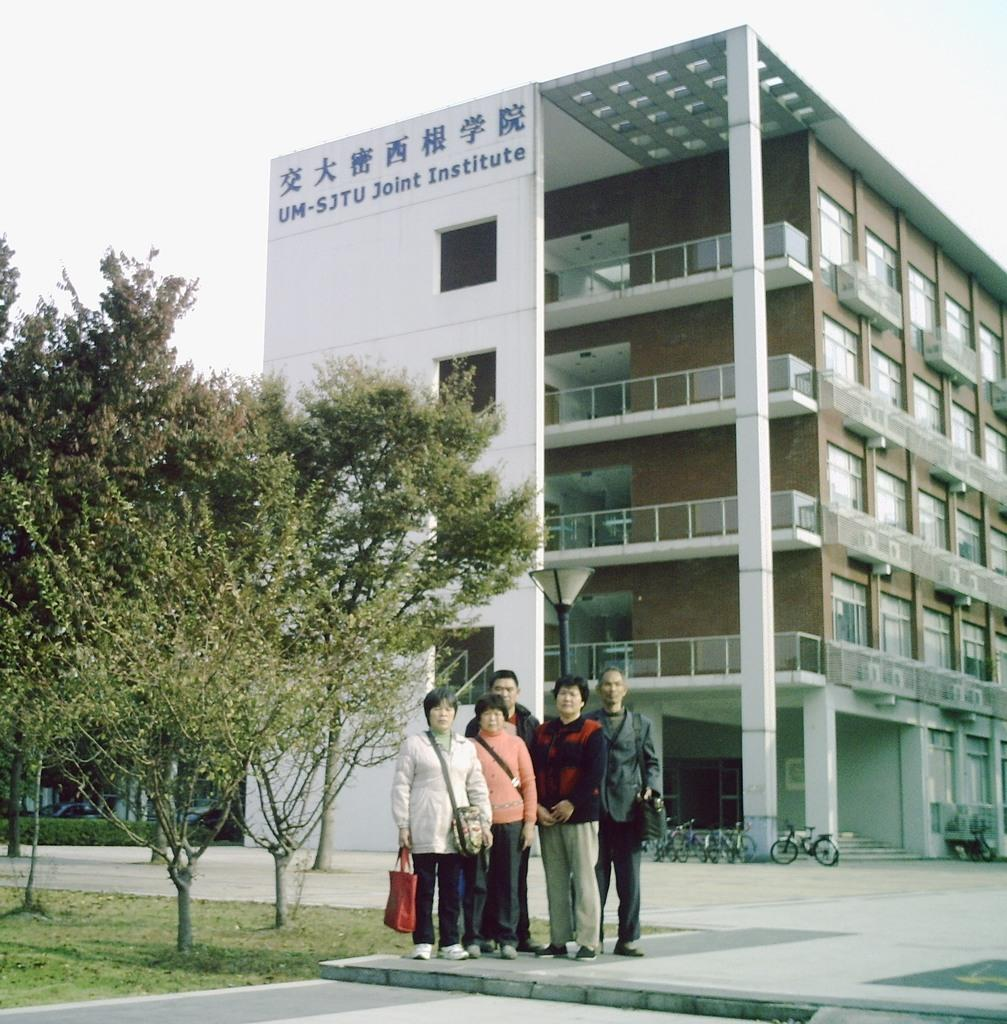What can be seen in the image? There are people standing in the image, along with trees, light poles, cycles parked, a building in the background, and the sky visible in the background. What type of vehicles are present in the image? Cycles are parked in the image. What architectural feature can be seen in the background of the image? There is a building in the background of the image. What is visible in the sky in the image? The sky is visible in the background of the image. Can you tell me how many grapes are hanging from the trees in the image? There are no grapes present in the image; the trees are not fruit-bearing trees. What type of work is the carpenter doing in the image? There is no carpenter present in the image. 